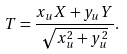<formula> <loc_0><loc_0><loc_500><loc_500>T = \frac { x _ { u } X + y _ { u } Y } { \sqrt { x _ { u } ^ { 2 } + y _ { u } ^ { 2 } } } .</formula> 